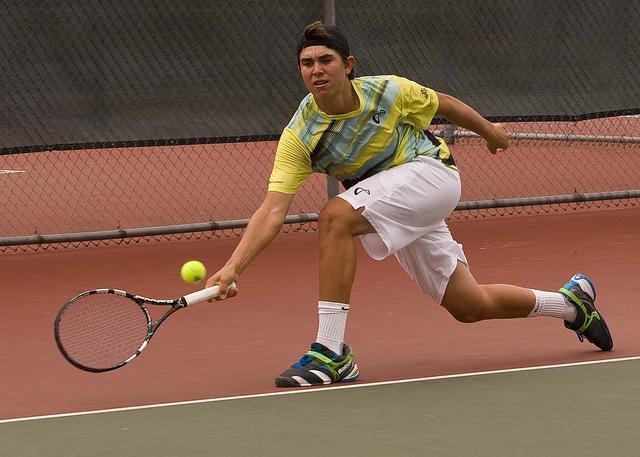What shot is he using to hit the ball?
From the following four choices, select the correct answer to address the question.
Options: Overhead, volley, backhand, forehand. Forehand. 